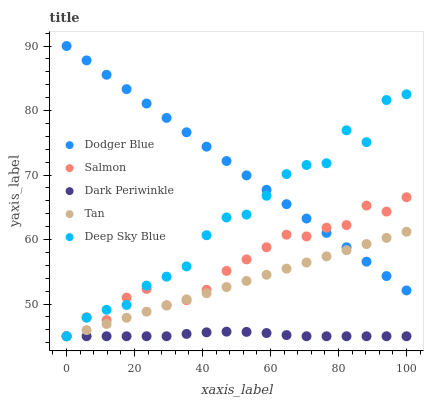Does Dark Periwinkle have the minimum area under the curve?
Answer yes or no. Yes. Does Dodger Blue have the maximum area under the curve?
Answer yes or no. Yes. Does Tan have the minimum area under the curve?
Answer yes or no. No. Does Tan have the maximum area under the curve?
Answer yes or no. No. Is Tan the smoothest?
Answer yes or no. Yes. Is Deep Sky Blue the roughest?
Answer yes or no. Yes. Is Dodger Blue the smoothest?
Answer yes or no. No. Is Dodger Blue the roughest?
Answer yes or no. No. Does Salmon have the lowest value?
Answer yes or no. Yes. Does Dodger Blue have the lowest value?
Answer yes or no. No. Does Dodger Blue have the highest value?
Answer yes or no. Yes. Does Tan have the highest value?
Answer yes or no. No. Is Dark Periwinkle less than Dodger Blue?
Answer yes or no. Yes. Is Dodger Blue greater than Dark Periwinkle?
Answer yes or no. Yes. Does Dodger Blue intersect Tan?
Answer yes or no. Yes. Is Dodger Blue less than Tan?
Answer yes or no. No. Is Dodger Blue greater than Tan?
Answer yes or no. No. Does Dark Periwinkle intersect Dodger Blue?
Answer yes or no. No. 